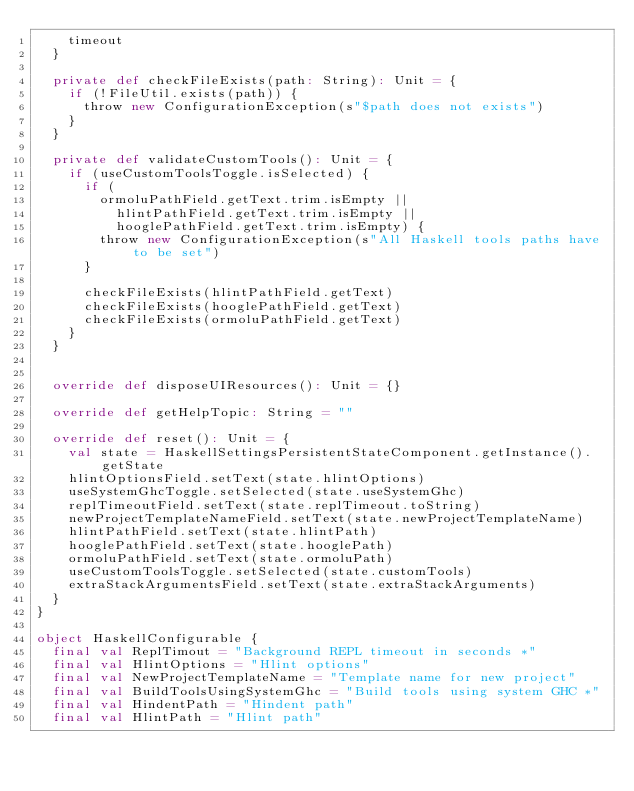Convert code to text. <code><loc_0><loc_0><loc_500><loc_500><_Scala_>    timeout
  }

  private def checkFileExists(path: String): Unit = {
    if (!FileUtil.exists(path)) {
      throw new ConfigurationException(s"$path does not exists")
    }
  }

  private def validateCustomTools(): Unit = {
    if (useCustomToolsToggle.isSelected) {
      if (
        ormoluPathField.getText.trim.isEmpty ||
          hlintPathField.getText.trim.isEmpty ||
          hooglePathField.getText.trim.isEmpty) {
        throw new ConfigurationException(s"All Haskell tools paths have to be set")
      }

      checkFileExists(hlintPathField.getText)
      checkFileExists(hooglePathField.getText)
      checkFileExists(ormoluPathField.getText)
    }
  }


  override def disposeUIResources(): Unit = {}

  override def getHelpTopic: String = ""

  override def reset(): Unit = {
    val state = HaskellSettingsPersistentStateComponent.getInstance().getState
    hlintOptionsField.setText(state.hlintOptions)
    useSystemGhcToggle.setSelected(state.useSystemGhc)
    replTimeoutField.setText(state.replTimeout.toString)
    newProjectTemplateNameField.setText(state.newProjectTemplateName)
    hlintPathField.setText(state.hlintPath)
    hooglePathField.setText(state.hooglePath)
    ormoluPathField.setText(state.ormoluPath)
    useCustomToolsToggle.setSelected(state.customTools)
    extraStackArgumentsField.setText(state.extraStackArguments)
  }
}

object HaskellConfigurable {
  final val ReplTimout = "Background REPL timeout in seconds *"
  final val HlintOptions = "Hlint options"
  final val NewProjectTemplateName = "Template name for new project"
  final val BuildToolsUsingSystemGhc = "Build tools using system GHC *"
  final val HindentPath = "Hindent path"
  final val HlintPath = "Hlint path"</code> 